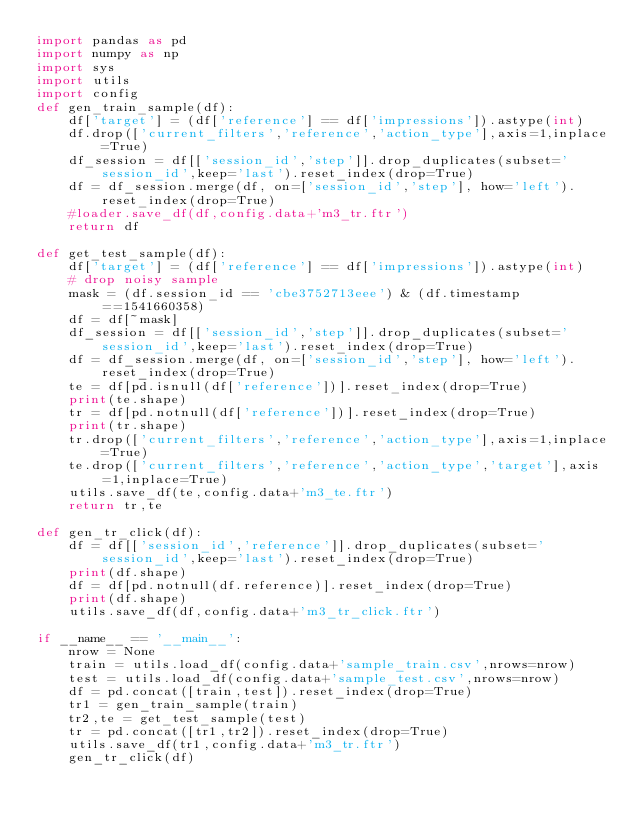<code> <loc_0><loc_0><loc_500><loc_500><_Python_>import pandas as pd
import numpy as np
import sys
import utils
import config
def gen_train_sample(df):
    df['target'] = (df['reference'] == df['impressions']).astype(int)
    df.drop(['current_filters','reference','action_type'],axis=1,inplace=True)
    df_session = df[['session_id','step']].drop_duplicates(subset='session_id',keep='last').reset_index(drop=True)
    df = df_session.merge(df, on=['session_id','step'], how='left').reset_index(drop=True)
    #loader.save_df(df,config.data+'m3_tr.ftr')
    return df

def get_test_sample(df):
    df['target'] = (df['reference'] == df['impressions']).astype(int)
    # drop noisy sample
    mask = (df.session_id == 'cbe3752713eee') & (df.timestamp ==1541660358)
    df = df[~mask]
    df_session = df[['session_id','step']].drop_duplicates(subset='session_id',keep='last').reset_index(drop=True)
    df = df_session.merge(df, on=['session_id','step'], how='left').reset_index(drop=True)
    te = df[pd.isnull(df['reference'])].reset_index(drop=True)
    print(te.shape)
    tr = df[pd.notnull(df['reference'])].reset_index(drop=True)
    print(tr.shape) 
    tr.drop(['current_filters','reference','action_type'],axis=1,inplace=True)
    te.drop(['current_filters','reference','action_type','target'],axis=1,inplace=True)
    utils.save_df(te,config.data+'m3_te.ftr')
    return tr,te

def gen_tr_click(df):
    df = df[['session_id','reference']].drop_duplicates(subset='session_id',keep='last').reset_index(drop=True)
    print(df.shape)
    df = df[pd.notnull(df.reference)].reset_index(drop=True)
    print(df.shape)
    utils.save_df(df,config.data+'m3_tr_click.ftr')

if __name__ == '__main__':
    nrow = None
    train = utils.load_df(config.data+'sample_train.csv',nrows=nrow)
    test = utils.load_df(config.data+'sample_test.csv',nrows=nrow)
    df = pd.concat([train,test]).reset_index(drop=True)
    tr1 = gen_train_sample(train)
    tr2,te = get_test_sample(test)
    tr = pd.concat([tr1,tr2]).reset_index(drop=True)
    utils.save_df(tr1,config.data+'m3_tr.ftr')
    gen_tr_click(df)
</code> 